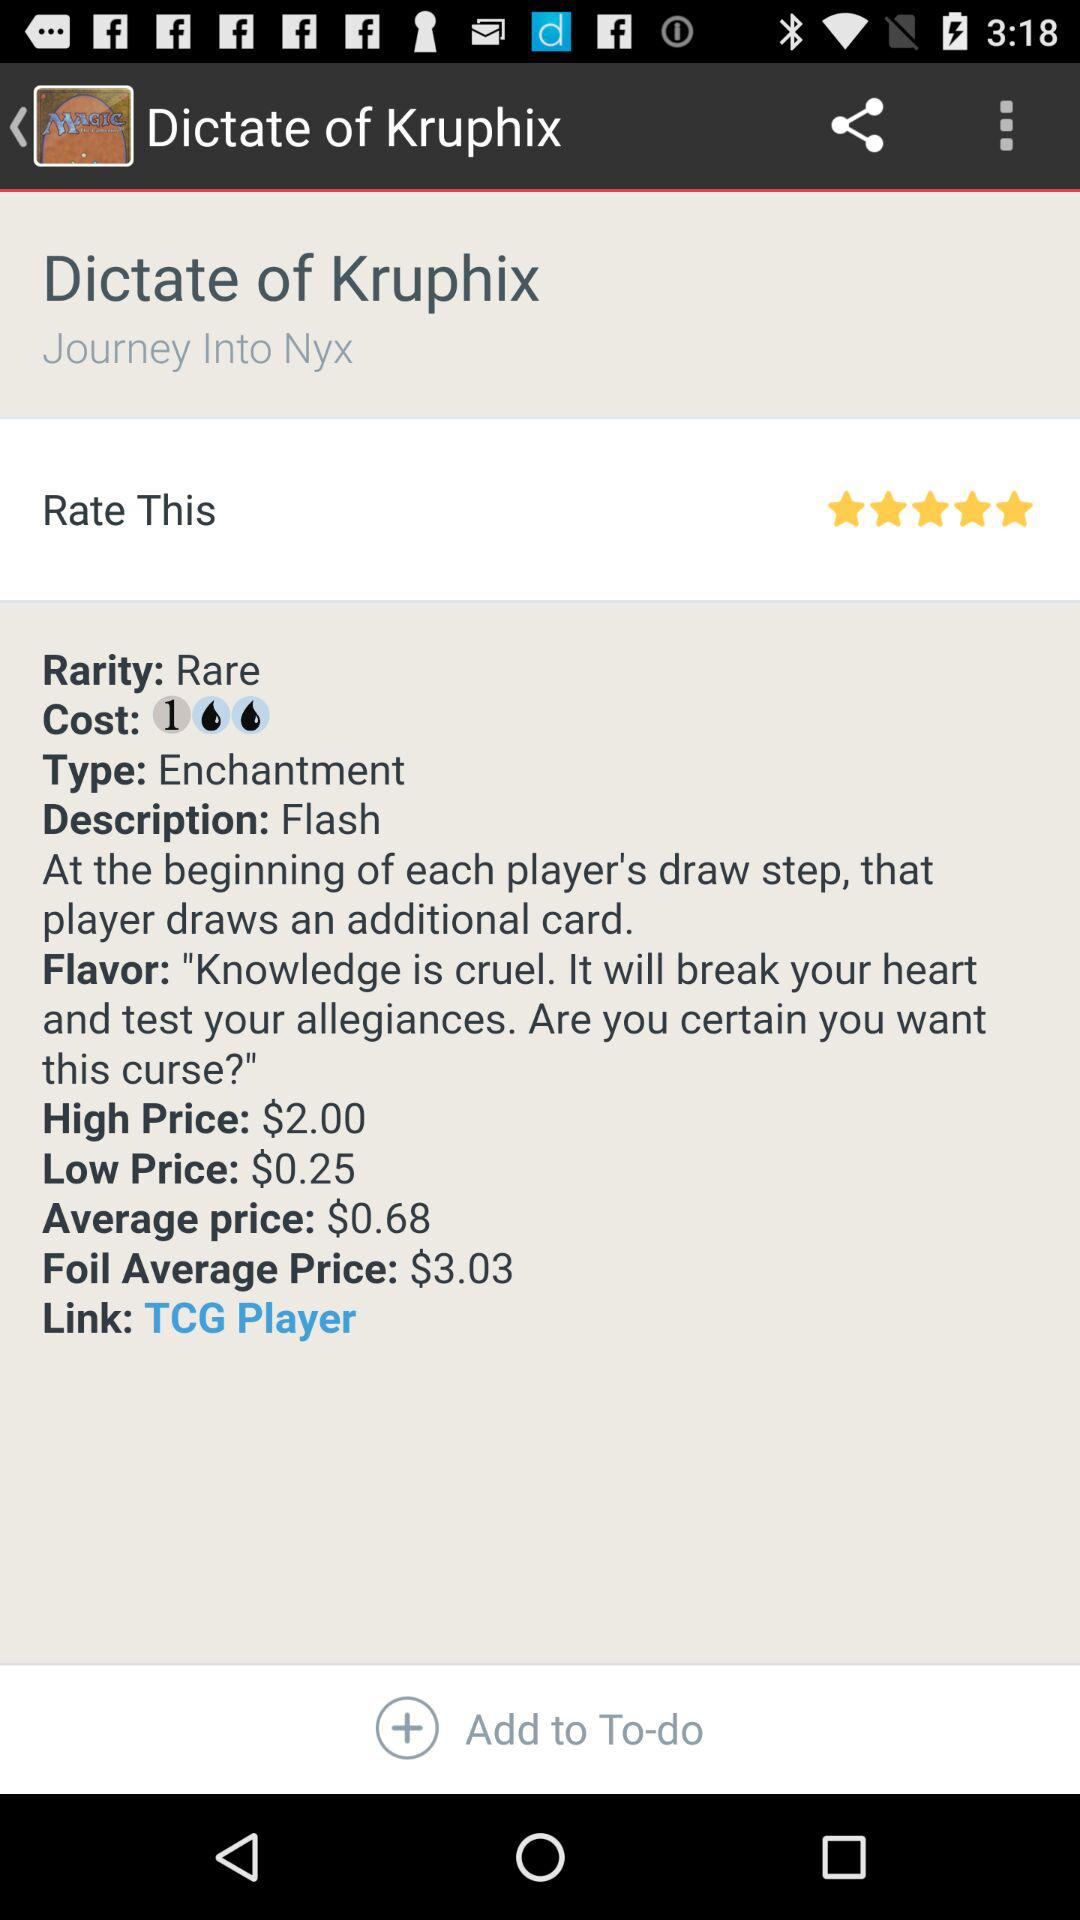What is the "Foil Average Price"? The "Foil Average Price" is $3.03. 